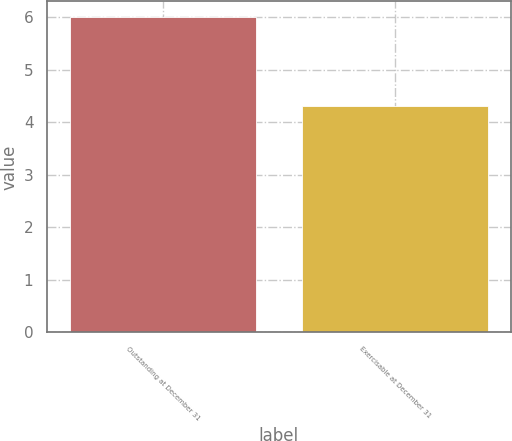<chart> <loc_0><loc_0><loc_500><loc_500><bar_chart><fcel>Outstanding at December 31<fcel>Exercisable at December 31<nl><fcel>6<fcel>4.3<nl></chart> 